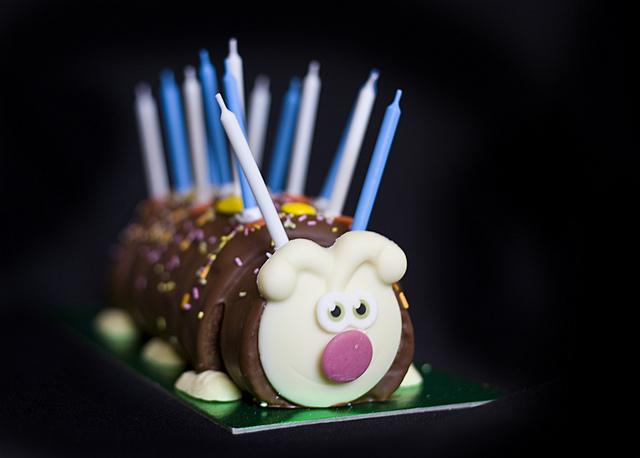What color are the candles?
Write a very short answer. Blue and white. What color are the feet?
Be succinct. White. What color is the nose on the cake?
Concise answer only. Pink. 